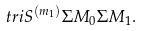<formula> <loc_0><loc_0><loc_500><loc_500>\ t r i { S ^ { ( m _ { 1 } ) } } { \Sigma M _ { 0 } } { \Sigma M _ { 1 } } .</formula> 